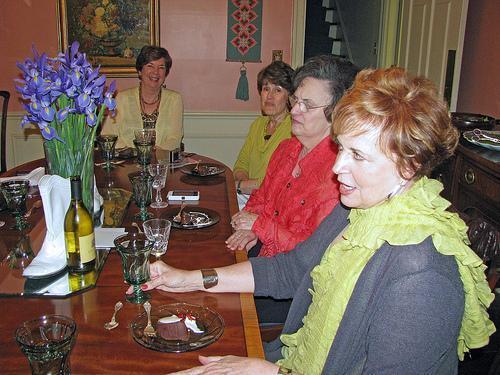How many bottles are there?
Give a very brief answer. 1. 